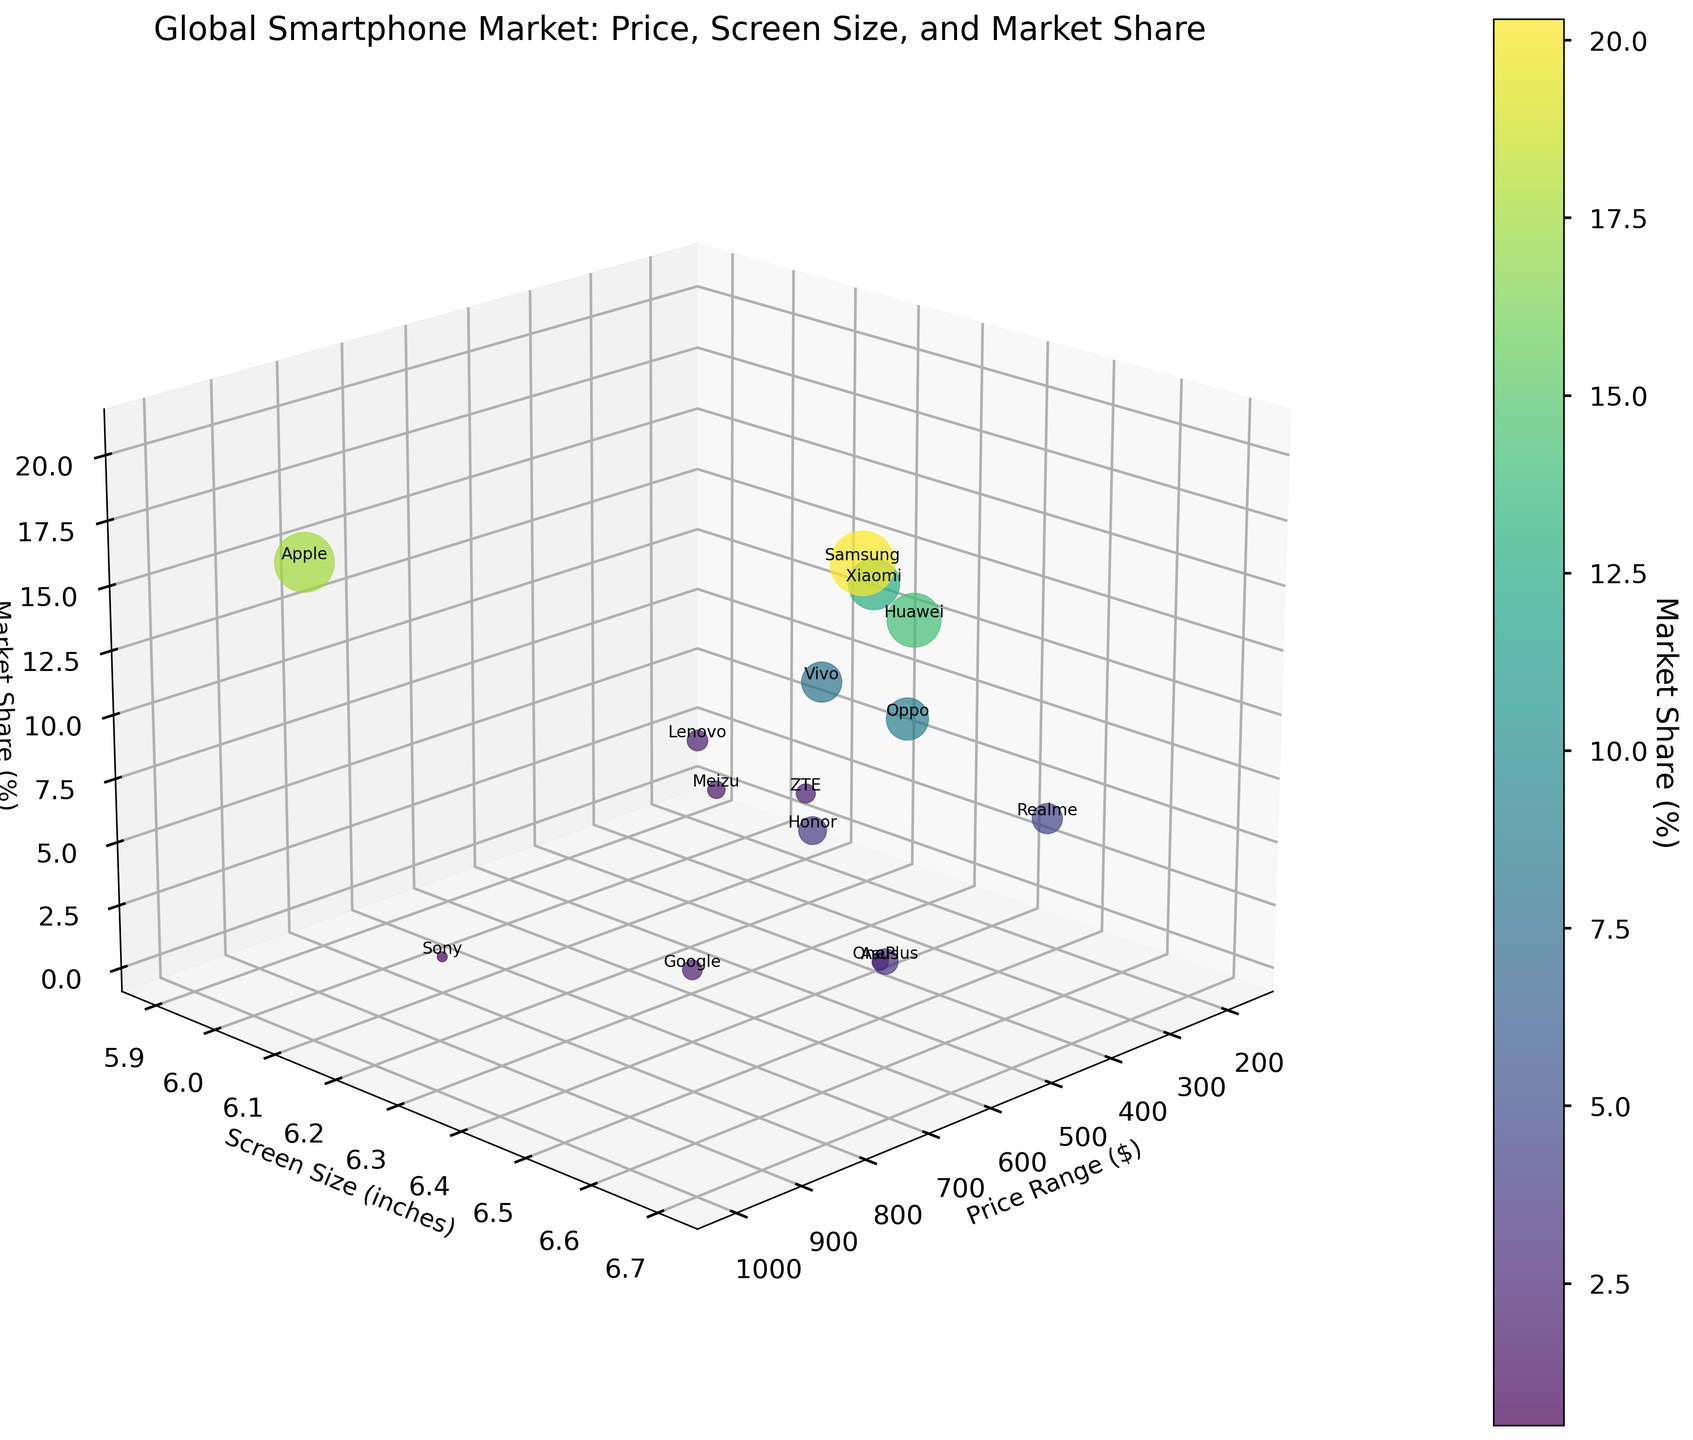What is the title of the plot? The title of the plot is located at the top and reads "Global Smartphone Market: Price, Screen Size, and Market Share".
Answer: Global Smartphone Market: Price, Screen Size, and Market Share How many data points are represented in the plot? By counting the different colored data points present in the 3D scatter plot, we find there are 15 distinct points.
Answer: 15 Which brand has the highest market share? By observing the Z-axis, the tallest point in the figure corresponds to the brand with the highest Market Share. This is Samsung with a 20.3% market share.
Answer: Samsung What is the price range and screen size of the Apple smartphone? Apple is labeled on the plot at coordinates corresponding to around \$999 on the X-axis (Price Range) and approximately 6.1 inches on the Y-axis (Screen Size).
Answer: Price Range: $999, Screen Size: 6.1 inches Which brand has the smallest screen size, and what is its market share? By comparing the Y-axis positions, the smallest screen size belongs to Lenovo at 5.9 inches. Upon looking at the Z-axis value at this coordinate, Lenovo’s market share is 2.1%.
Answer: Lenovo, Market Share: 2.1% Between Xiaomi and Oppo, which brand has a higher market share, and by how much? By comparing the Z-axis (Market Share) values of Xiaomi and Oppo, Xiaomi has a 12.8% market share while Oppo has 8.7%. The difference is calculated as 12.8% - 8.7% = 4.1%.
Answer: Xiaomi, Difference: 4.1% Which two brands have a similar screen size of 6.5 inches, and how do their market shares compare? By locating all points with a Y-axis (Screen Size) value of approximately 6.5 inches, we see Huawei and Realme. Comparing their Z-axis values, Huawei has a market share of 14.2%, while Realme has 4.5%, so Huawei has a higher market share.
Answer: Huawei and Realme, Huawei has a higher market share What is the average market share of brands with a screen size of 6.3 inches? Identifying the brands with a screen size of 6.3 inches, they are Xiaomi and Honor with market shares 12.8% and 3.8% respectively. The average market share is calculated as (12.8 + 3.8) / 2 = 8.3%.
Answer: 8.3% Which brand in the plot has the highest price point, and what is its market share? The highest value on the X-axis (Price Range) indicates Apple at \$999. Observing its Z-axis value, Apple’s market share is 17.5%.
Answer: Apple, Market Share: 17.5% Is there any brand with a price range lower than $200 and what is its market share? By examining the points on the X-axis (Price Range) below \$200, Lenovo has a price range of \$180. Its market share, seen on the Z-axis, is 2.1%.
Answer: Lenovo, Market Share: 2.1% 